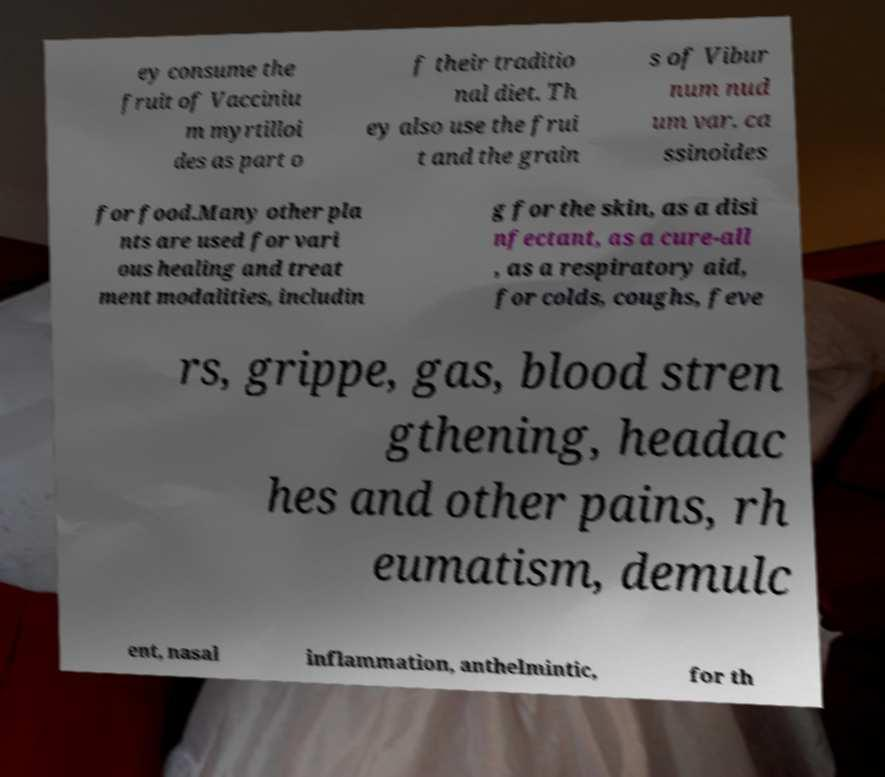Could you assist in decoding the text presented in this image and type it out clearly? ey consume the fruit of Vacciniu m myrtilloi des as part o f their traditio nal diet. Th ey also use the frui t and the grain s of Vibur num nud um var. ca ssinoides for food.Many other pla nts are used for vari ous healing and treat ment modalities, includin g for the skin, as a disi nfectant, as a cure-all , as a respiratory aid, for colds, coughs, feve rs, grippe, gas, blood stren gthening, headac hes and other pains, rh eumatism, demulc ent, nasal inflammation, anthelmintic, for th 